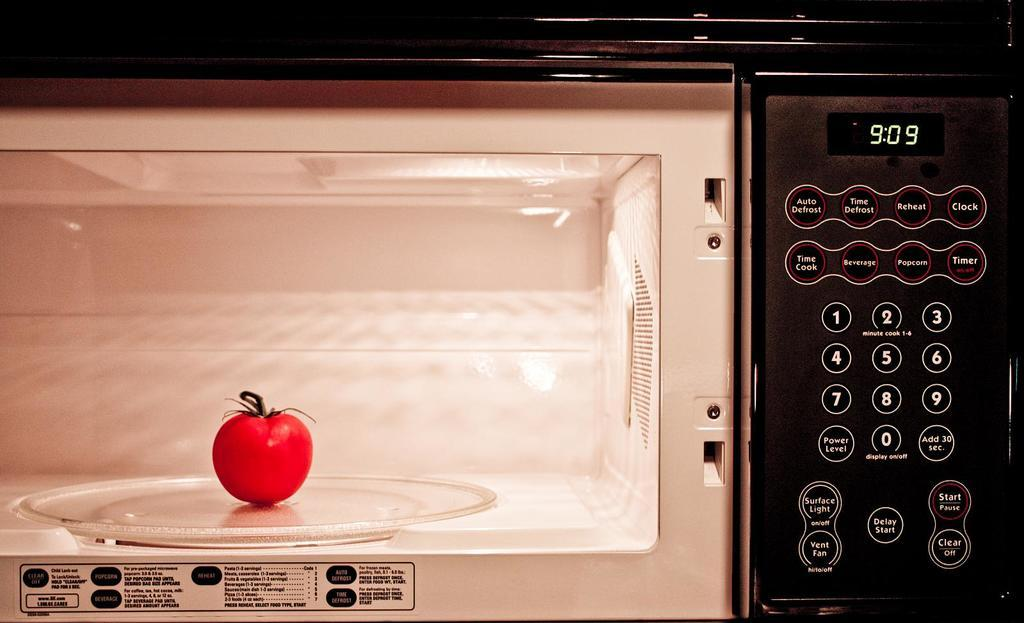What is the main subject of the image? The main subject of the image is a tomato. Where is the tomato located in the image? The tomato is in an oven. How many glasses of wine are on the table in the image? There is no table or wine glasses present in the image; it only features a tomato in an oven. 